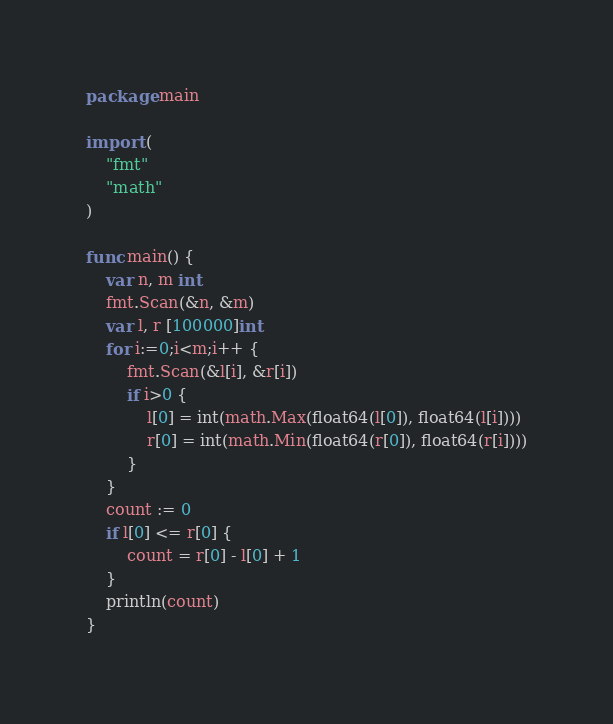<code> <loc_0><loc_0><loc_500><loc_500><_Go_>package main

import (
	"fmt"
	"math"
)

func main() {
	var n, m int
	fmt.Scan(&n, &m)
	var l, r [100000]int
	for i:=0;i<m;i++ {
		fmt.Scan(&l[i], &r[i])
		if i>0 {
			l[0] = int(math.Max(float64(l[0]), float64(l[i])))
			r[0] = int(math.Min(float64(r[0]), float64(r[i])))
		}
	}
	count := 0
	if l[0] <= r[0] {
		count = r[0] - l[0] + 1
	}
	println(count)
}</code> 